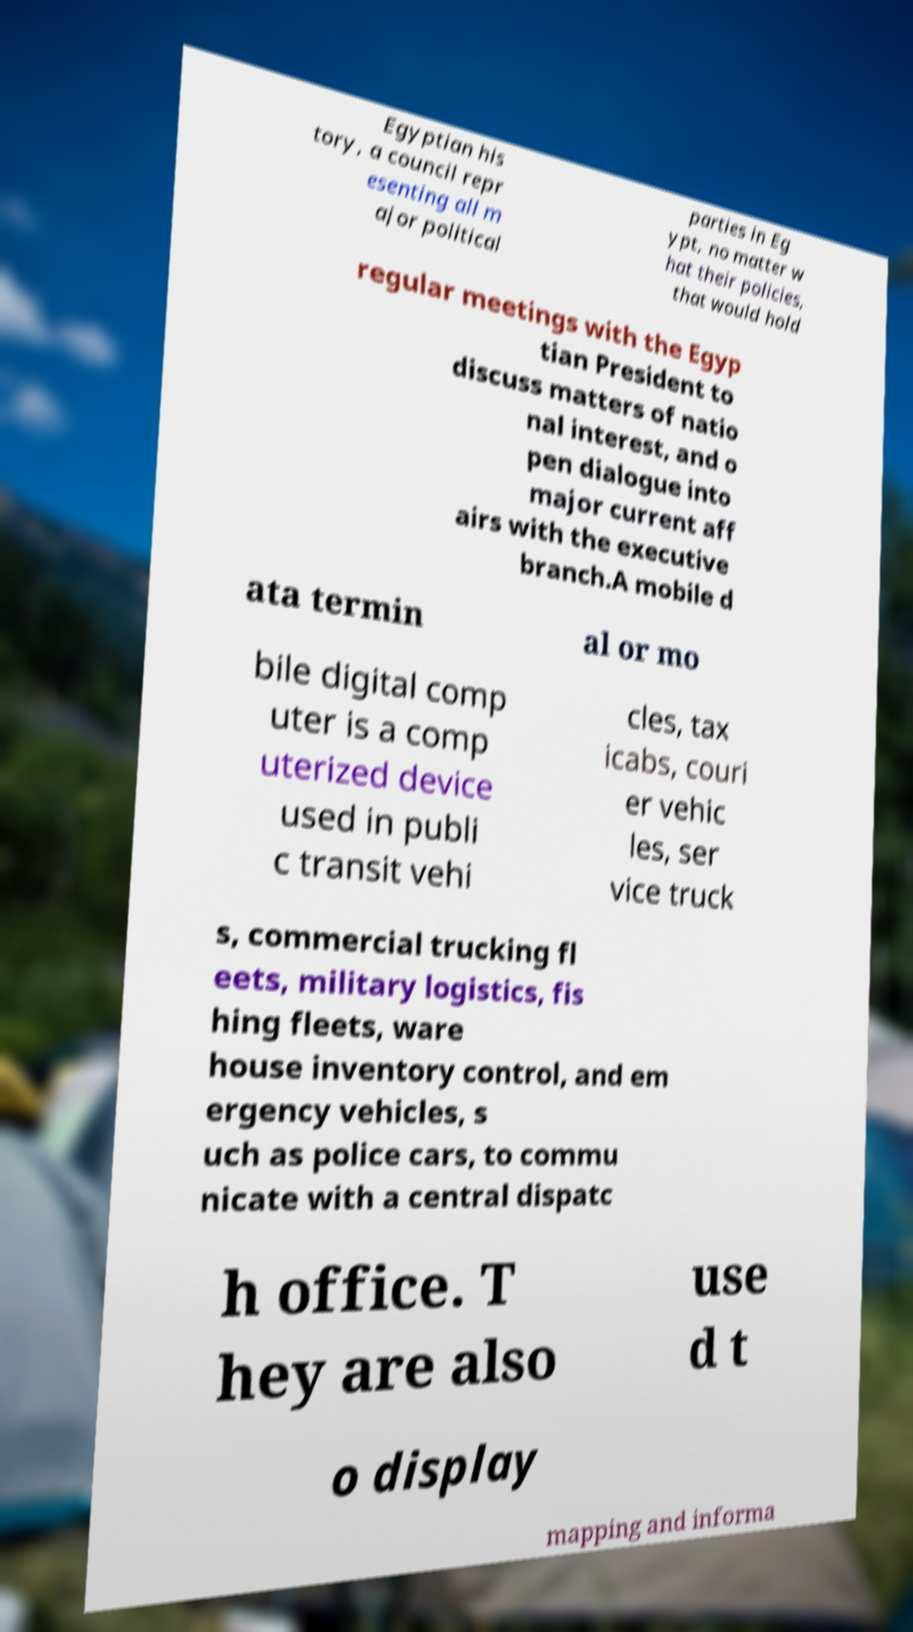Can you accurately transcribe the text from the provided image for me? Egyptian his tory, a council repr esenting all m ajor political parties in Eg ypt, no matter w hat their policies, that would hold regular meetings with the Egyp tian President to discuss matters of natio nal interest, and o pen dialogue into major current aff airs with the executive branch.A mobile d ata termin al or mo bile digital comp uter is a comp uterized device used in publi c transit vehi cles, tax icabs, couri er vehic les, ser vice truck s, commercial trucking fl eets, military logistics, fis hing fleets, ware house inventory control, and em ergency vehicles, s uch as police cars, to commu nicate with a central dispatc h office. T hey are also use d t o display mapping and informa 